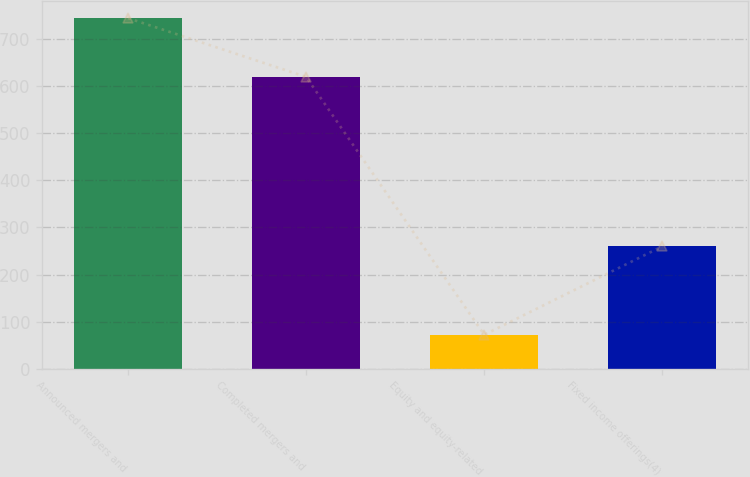<chart> <loc_0><loc_0><loc_500><loc_500><bar_chart><fcel>Announced mergers and<fcel>Completed mergers and<fcel>Equity and equity-related<fcel>Fixed income offerings(4)<nl><fcel>745<fcel>620<fcel>72<fcel>260<nl></chart> 